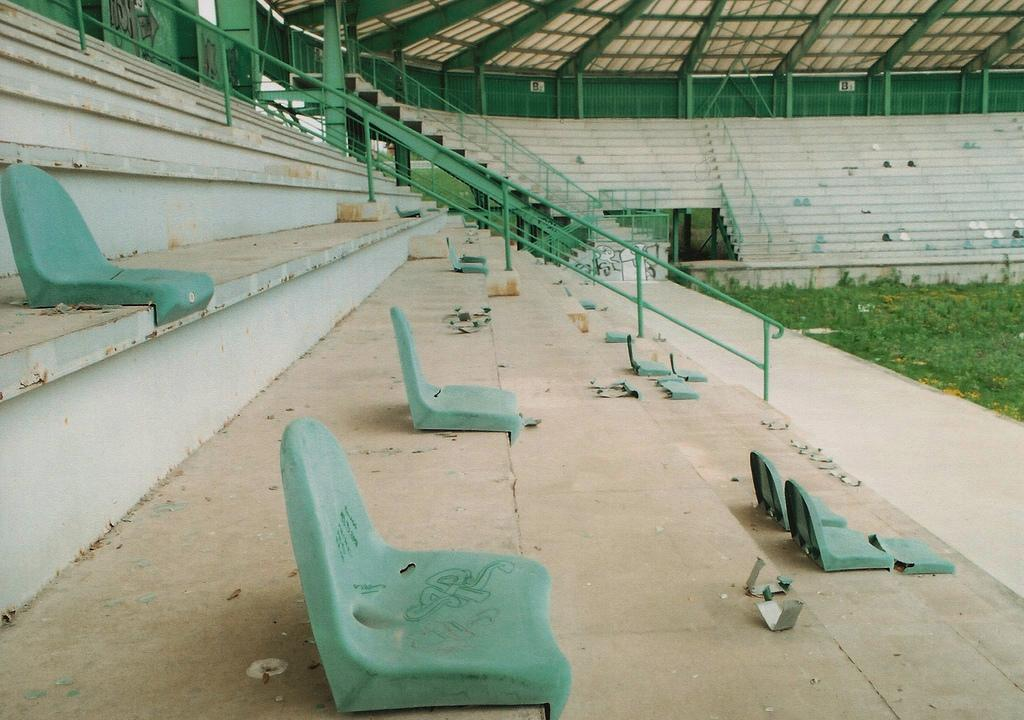What is the main structure visible in the image? There is a stadium in the image. What type of seating is available in the stadium? There are chairs in the stadium. What type of surface is on the ground in the stadium? There is grass on the ground in the stadium. How can people access different levels of the stadium? There are stairs in the stadium to climb. What type of rake is being used to maintain the grass in the image? There is no rake visible in the image, and the grass maintenance is not mentioned. What is the purpose of the stadium in the downtown area? The image does not specify the location of the stadium as being in a downtown area, nor does it mention the purpose of the stadium. 